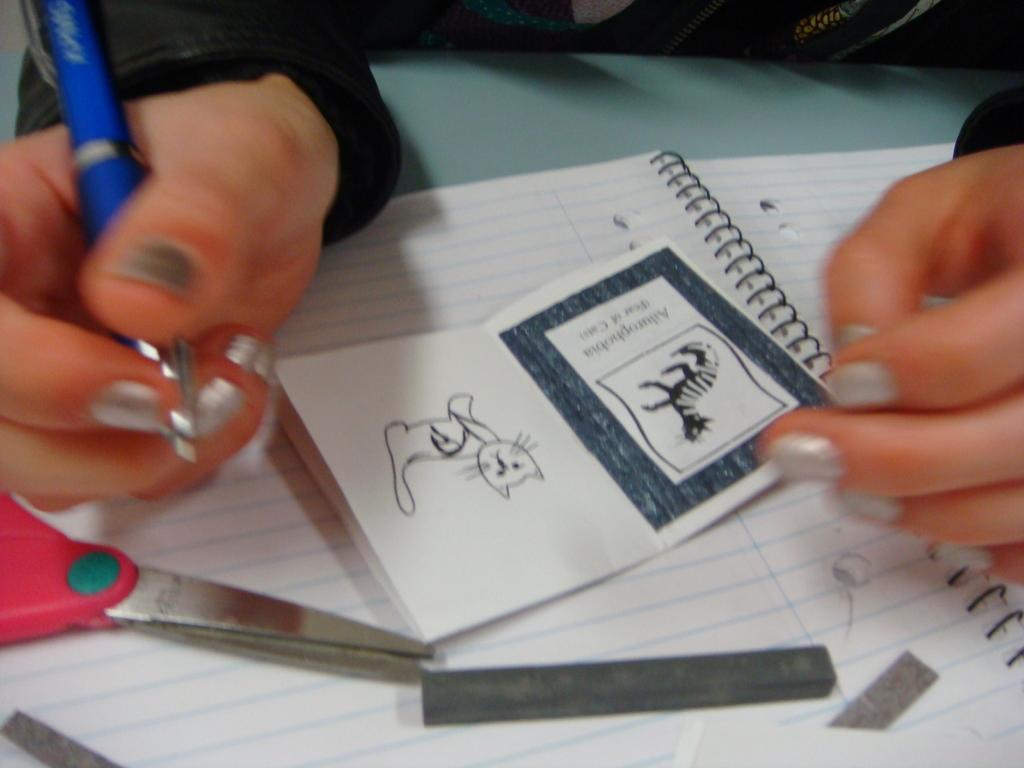Please provide a concise description of this image. In the picture we can see a table and a book with a person's hand holding a pen and on the book we can see a small book with some drawing on it and besides we can see a scissors and a blade. 